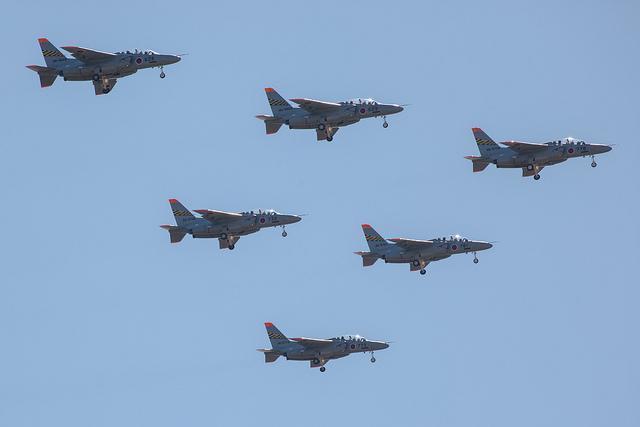How many airplanes are visible?
Give a very brief answer. 6. 